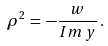<formula> <loc_0><loc_0><loc_500><loc_500>\rho ^ { 2 } \, = \, - \frac { w } { I m \, y } \, .</formula> 